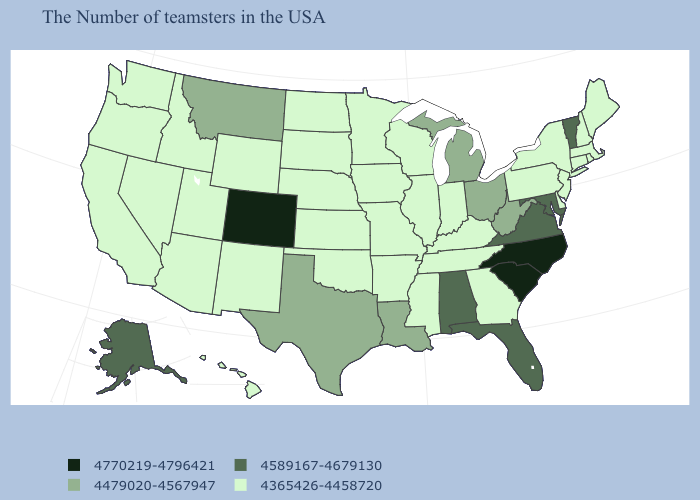Among the states that border Montana , which have the lowest value?
Quick response, please. South Dakota, North Dakota, Wyoming, Idaho. Among the states that border New Mexico , does Colorado have the highest value?
Keep it brief. Yes. Does Massachusetts have the lowest value in the USA?
Answer briefly. Yes. Among the states that border Virginia , which have the highest value?
Concise answer only. North Carolina. Name the states that have a value in the range 4479020-4567947?
Give a very brief answer. West Virginia, Ohio, Michigan, Louisiana, Texas, Montana. Does Nevada have the highest value in the West?
Concise answer only. No. Name the states that have a value in the range 4589167-4679130?
Quick response, please. Vermont, Maryland, Virginia, Florida, Alabama, Alaska. Does Rhode Island have the same value as Oklahoma?
Write a very short answer. Yes. What is the lowest value in the USA?
Concise answer only. 4365426-4458720. What is the value of Oklahoma?
Write a very short answer. 4365426-4458720. What is the lowest value in states that border California?
Keep it brief. 4365426-4458720. What is the value of New York?
Be succinct. 4365426-4458720. What is the value of Iowa?
Be succinct. 4365426-4458720. Name the states that have a value in the range 4770219-4796421?
Answer briefly. North Carolina, South Carolina, Colorado. Name the states that have a value in the range 4770219-4796421?
Answer briefly. North Carolina, South Carolina, Colorado. 